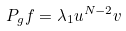<formula> <loc_0><loc_0><loc_500><loc_500>P _ { g } f = \lambda _ { 1 } u ^ { N - 2 } v</formula> 